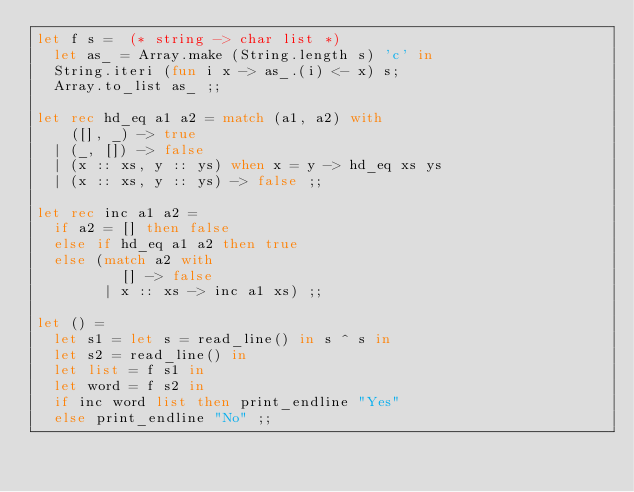<code> <loc_0><loc_0><loc_500><loc_500><_OCaml_>let f s =  (* string -> char list *)
  let as_ = Array.make (String.length s) 'c' in 
  String.iteri (fun i x -> as_.(i) <- x) s;
  Array.to_list as_ ;;

let rec hd_eq a1 a2 = match (a1, a2) with
    ([], _) -> true
  | (_, []) -> false
  | (x :: xs, y :: ys) when x = y -> hd_eq xs ys
  | (x :: xs, y :: ys) -> false ;;

let rec inc a1 a2 =
  if a2 = [] then false
  else if hd_eq a1 a2 then true
  else (match a2 with
          [] -> false
        | x :: xs -> inc a1 xs) ;;

let () =
  let s1 = let s = read_line() in s ^ s in
  let s2 = read_line() in
  let list = f s1 in
  let word = f s2 in
  if inc word list then print_endline "Yes"
  else print_endline "No" ;;
</code> 